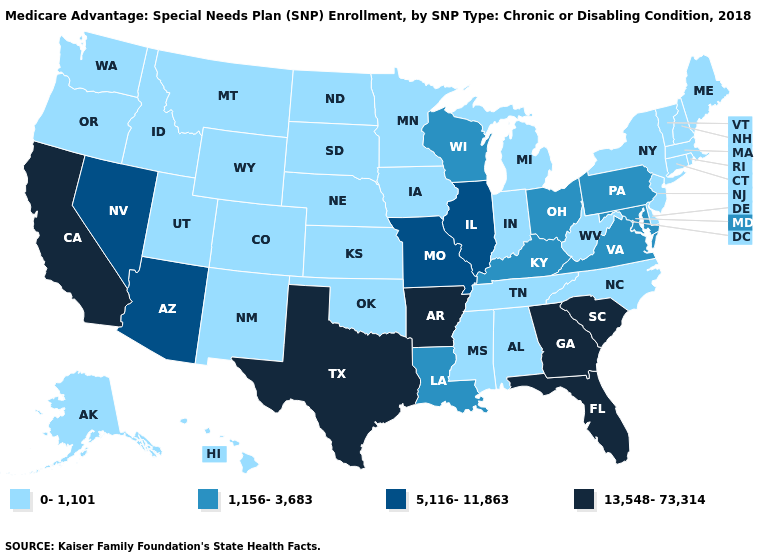Among the states that border Texas , which have the lowest value?
Concise answer only. New Mexico, Oklahoma. Name the states that have a value in the range 5,116-11,863?
Keep it brief. Arizona, Illinois, Missouri, Nevada. Among the states that border Maryland , does Pennsylvania have the lowest value?
Concise answer only. No. Does Arkansas have the lowest value in the South?
Give a very brief answer. No. What is the value of Pennsylvania?
Keep it brief. 1,156-3,683. Which states hav the highest value in the MidWest?
Write a very short answer. Illinois, Missouri. Does Georgia have a higher value than California?
Write a very short answer. No. Does the first symbol in the legend represent the smallest category?
Answer briefly. Yes. Name the states that have a value in the range 1,156-3,683?
Be succinct. Kentucky, Louisiana, Maryland, Ohio, Pennsylvania, Virginia, Wisconsin. Name the states that have a value in the range 13,548-73,314?
Concise answer only. Arkansas, California, Florida, Georgia, South Carolina, Texas. What is the value of Indiana?
Write a very short answer. 0-1,101. Does the map have missing data?
Keep it brief. No. Does the map have missing data?
Concise answer only. No. Does North Dakota have the highest value in the USA?
Concise answer only. No. What is the value of Delaware?
Short answer required. 0-1,101. 